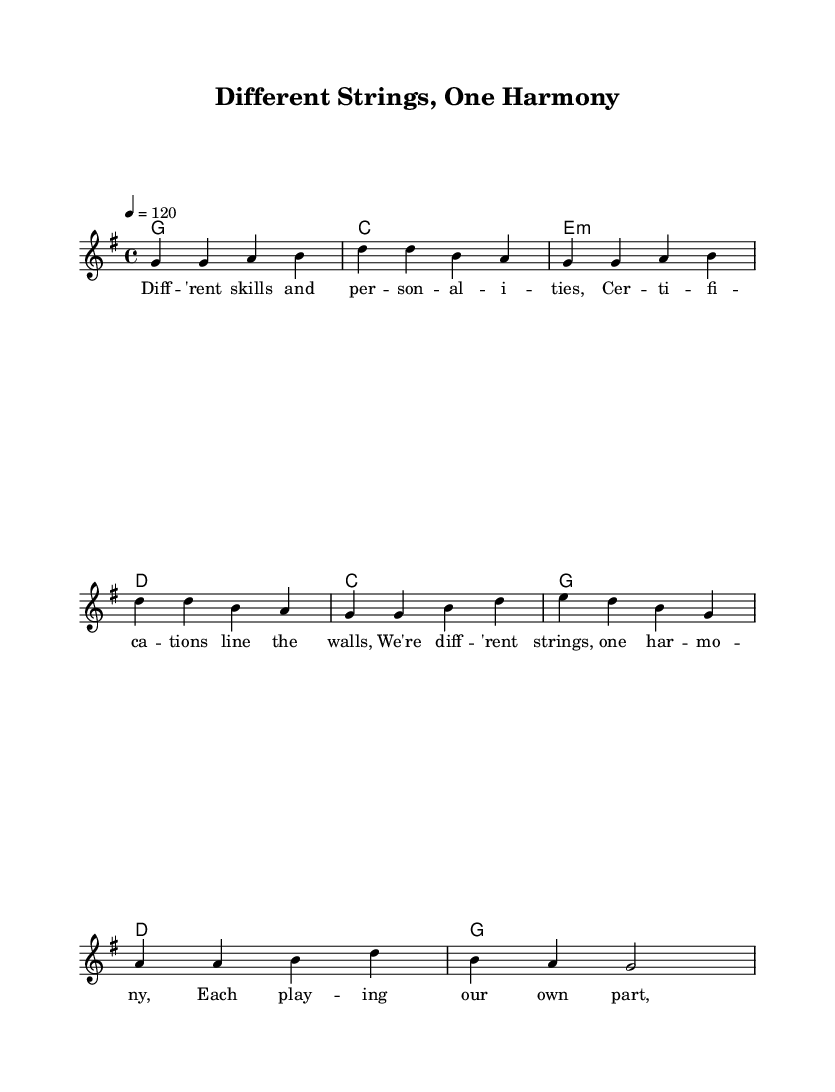What is the key signature of this music? The key signature is G major, which has one sharp (F#).
Answer: G major What is the time signature of this music? The time signature is 4/4, meaning there are four beats per measure and each quarter note receives one beat.
Answer: 4/4 What is the tempo indication for this piece? The tempo is marked as quarter note equals 120 beats per minute, indicating a moderately fast pace.
Answer: 120 How many chords are indicated in the verse? The verse consists of four chords: G, C, E minor, and D, as shown in the chord progression.
Answer: Four Which section of the song contains the lyrics about 'different skills and personalities'? The lyrics about 'different skills and personalities' are found in the verse, as described in the lyrics of the song.
Answer: Verse How does the structure of this song reflect managing diverse teams? The structure reflects managing diverse teams through the lyrics emphasizing unity in diversity, highlighting different strengths harmonizing together.
Answer: Unity in diversity What is the primary theme of the lyrics? The primary theme of the lyrics revolves around collaboration and recognizing individual contributions to achieve harmony as a team.
Answer: Collaboration 